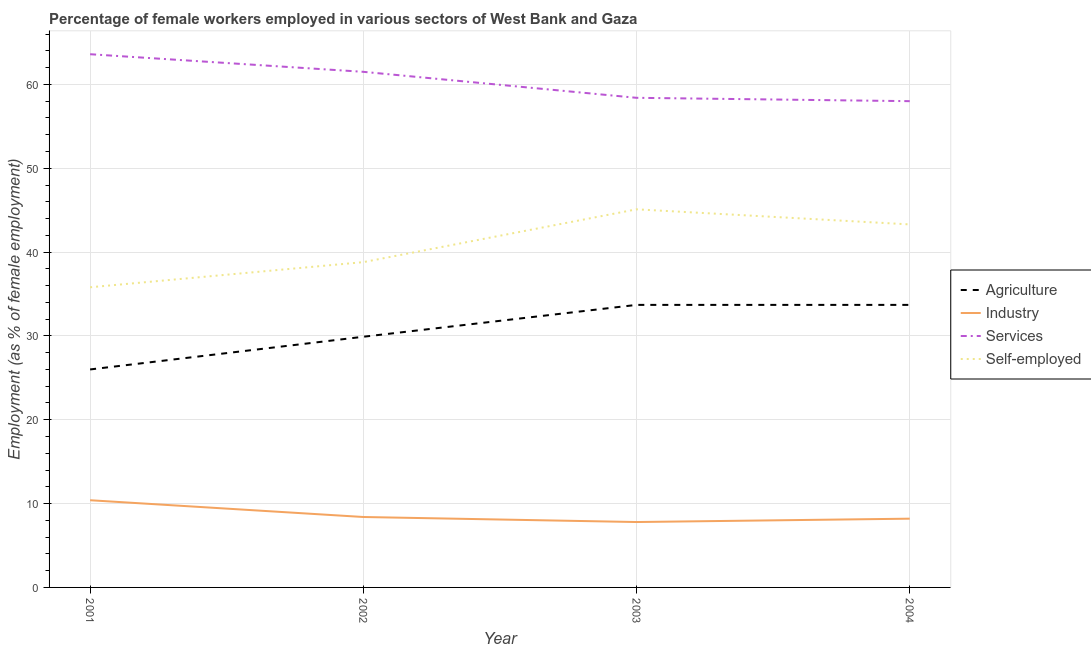How many different coloured lines are there?
Keep it short and to the point. 4. What is the percentage of female workers in industry in 2001?
Your answer should be very brief. 10.4. Across all years, what is the maximum percentage of female workers in services?
Make the answer very short. 63.6. Across all years, what is the minimum percentage of female workers in services?
Keep it short and to the point. 58. In which year was the percentage of female workers in agriculture minimum?
Your answer should be compact. 2001. What is the total percentage of female workers in agriculture in the graph?
Provide a succinct answer. 123.3. What is the difference between the percentage of female workers in industry in 2002 and that in 2004?
Give a very brief answer. 0.2. What is the average percentage of female workers in agriculture per year?
Offer a very short reply. 30.83. In the year 2002, what is the difference between the percentage of self employed female workers and percentage of female workers in services?
Provide a succinct answer. -22.7. In how many years, is the percentage of female workers in industry greater than 18 %?
Provide a succinct answer. 0. What is the ratio of the percentage of female workers in services in 2003 to that in 2004?
Keep it short and to the point. 1.01. Is the percentage of female workers in industry in 2003 less than that in 2004?
Provide a succinct answer. Yes. Is the difference between the percentage of female workers in agriculture in 2001 and 2004 greater than the difference between the percentage of self employed female workers in 2001 and 2004?
Your answer should be very brief. No. What is the difference between the highest and the lowest percentage of female workers in services?
Your answer should be very brief. 5.6. Is the sum of the percentage of self employed female workers in 2003 and 2004 greater than the maximum percentage of female workers in industry across all years?
Give a very brief answer. Yes. Is the percentage of female workers in industry strictly greater than the percentage of self employed female workers over the years?
Give a very brief answer. No. How many lines are there?
Keep it short and to the point. 4. How many years are there in the graph?
Ensure brevity in your answer.  4. What is the difference between two consecutive major ticks on the Y-axis?
Give a very brief answer. 10. Are the values on the major ticks of Y-axis written in scientific E-notation?
Provide a succinct answer. No. Does the graph contain any zero values?
Offer a terse response. No. How many legend labels are there?
Make the answer very short. 4. How are the legend labels stacked?
Ensure brevity in your answer.  Vertical. What is the title of the graph?
Offer a very short reply. Percentage of female workers employed in various sectors of West Bank and Gaza. Does "Agricultural land" appear as one of the legend labels in the graph?
Offer a terse response. No. What is the label or title of the X-axis?
Your answer should be compact. Year. What is the label or title of the Y-axis?
Ensure brevity in your answer.  Employment (as % of female employment). What is the Employment (as % of female employment) of Industry in 2001?
Offer a very short reply. 10.4. What is the Employment (as % of female employment) in Services in 2001?
Provide a succinct answer. 63.6. What is the Employment (as % of female employment) in Self-employed in 2001?
Provide a short and direct response. 35.8. What is the Employment (as % of female employment) in Agriculture in 2002?
Your answer should be very brief. 29.9. What is the Employment (as % of female employment) in Industry in 2002?
Make the answer very short. 8.4. What is the Employment (as % of female employment) in Services in 2002?
Provide a short and direct response. 61.5. What is the Employment (as % of female employment) in Self-employed in 2002?
Your answer should be very brief. 38.8. What is the Employment (as % of female employment) of Agriculture in 2003?
Your answer should be very brief. 33.7. What is the Employment (as % of female employment) in Industry in 2003?
Offer a terse response. 7.8. What is the Employment (as % of female employment) in Services in 2003?
Offer a very short reply. 58.4. What is the Employment (as % of female employment) of Self-employed in 2003?
Your answer should be very brief. 45.1. What is the Employment (as % of female employment) of Agriculture in 2004?
Offer a very short reply. 33.7. What is the Employment (as % of female employment) of Industry in 2004?
Give a very brief answer. 8.2. What is the Employment (as % of female employment) in Services in 2004?
Offer a terse response. 58. What is the Employment (as % of female employment) of Self-employed in 2004?
Offer a terse response. 43.3. Across all years, what is the maximum Employment (as % of female employment) in Agriculture?
Keep it short and to the point. 33.7. Across all years, what is the maximum Employment (as % of female employment) in Industry?
Make the answer very short. 10.4. Across all years, what is the maximum Employment (as % of female employment) of Services?
Provide a short and direct response. 63.6. Across all years, what is the maximum Employment (as % of female employment) of Self-employed?
Ensure brevity in your answer.  45.1. Across all years, what is the minimum Employment (as % of female employment) of Industry?
Give a very brief answer. 7.8. Across all years, what is the minimum Employment (as % of female employment) of Self-employed?
Give a very brief answer. 35.8. What is the total Employment (as % of female employment) in Agriculture in the graph?
Offer a very short reply. 123.3. What is the total Employment (as % of female employment) in Industry in the graph?
Make the answer very short. 34.8. What is the total Employment (as % of female employment) of Services in the graph?
Your response must be concise. 241.5. What is the total Employment (as % of female employment) of Self-employed in the graph?
Offer a very short reply. 163. What is the difference between the Employment (as % of female employment) of Industry in 2001 and that in 2002?
Provide a succinct answer. 2. What is the difference between the Employment (as % of female employment) of Services in 2001 and that in 2002?
Your answer should be very brief. 2.1. What is the difference between the Employment (as % of female employment) in Agriculture in 2001 and that in 2003?
Give a very brief answer. -7.7. What is the difference between the Employment (as % of female employment) of Services in 2001 and that in 2003?
Keep it short and to the point. 5.2. What is the difference between the Employment (as % of female employment) of Self-employed in 2001 and that in 2003?
Make the answer very short. -9.3. What is the difference between the Employment (as % of female employment) of Industry in 2001 and that in 2004?
Your answer should be compact. 2.2. What is the difference between the Employment (as % of female employment) in Services in 2001 and that in 2004?
Offer a very short reply. 5.6. What is the difference between the Employment (as % of female employment) in Self-employed in 2001 and that in 2004?
Provide a short and direct response. -7.5. What is the difference between the Employment (as % of female employment) of Services in 2002 and that in 2003?
Keep it short and to the point. 3.1. What is the difference between the Employment (as % of female employment) in Agriculture in 2002 and that in 2004?
Ensure brevity in your answer.  -3.8. What is the difference between the Employment (as % of female employment) of Services in 2002 and that in 2004?
Your answer should be very brief. 3.5. What is the difference between the Employment (as % of female employment) in Agriculture in 2003 and that in 2004?
Provide a succinct answer. 0. What is the difference between the Employment (as % of female employment) in Industry in 2003 and that in 2004?
Make the answer very short. -0.4. What is the difference between the Employment (as % of female employment) in Services in 2003 and that in 2004?
Give a very brief answer. 0.4. What is the difference between the Employment (as % of female employment) of Self-employed in 2003 and that in 2004?
Give a very brief answer. 1.8. What is the difference between the Employment (as % of female employment) in Agriculture in 2001 and the Employment (as % of female employment) in Industry in 2002?
Ensure brevity in your answer.  17.6. What is the difference between the Employment (as % of female employment) in Agriculture in 2001 and the Employment (as % of female employment) in Services in 2002?
Your response must be concise. -35.5. What is the difference between the Employment (as % of female employment) of Agriculture in 2001 and the Employment (as % of female employment) of Self-employed in 2002?
Offer a terse response. -12.8. What is the difference between the Employment (as % of female employment) of Industry in 2001 and the Employment (as % of female employment) of Services in 2002?
Your answer should be very brief. -51.1. What is the difference between the Employment (as % of female employment) in Industry in 2001 and the Employment (as % of female employment) in Self-employed in 2002?
Offer a terse response. -28.4. What is the difference between the Employment (as % of female employment) of Services in 2001 and the Employment (as % of female employment) of Self-employed in 2002?
Give a very brief answer. 24.8. What is the difference between the Employment (as % of female employment) in Agriculture in 2001 and the Employment (as % of female employment) in Industry in 2003?
Your answer should be compact. 18.2. What is the difference between the Employment (as % of female employment) of Agriculture in 2001 and the Employment (as % of female employment) of Services in 2003?
Your response must be concise. -32.4. What is the difference between the Employment (as % of female employment) of Agriculture in 2001 and the Employment (as % of female employment) of Self-employed in 2003?
Make the answer very short. -19.1. What is the difference between the Employment (as % of female employment) of Industry in 2001 and the Employment (as % of female employment) of Services in 2003?
Offer a terse response. -48. What is the difference between the Employment (as % of female employment) of Industry in 2001 and the Employment (as % of female employment) of Self-employed in 2003?
Keep it short and to the point. -34.7. What is the difference between the Employment (as % of female employment) of Agriculture in 2001 and the Employment (as % of female employment) of Industry in 2004?
Make the answer very short. 17.8. What is the difference between the Employment (as % of female employment) of Agriculture in 2001 and the Employment (as % of female employment) of Services in 2004?
Offer a very short reply. -32. What is the difference between the Employment (as % of female employment) of Agriculture in 2001 and the Employment (as % of female employment) of Self-employed in 2004?
Your response must be concise. -17.3. What is the difference between the Employment (as % of female employment) of Industry in 2001 and the Employment (as % of female employment) of Services in 2004?
Keep it short and to the point. -47.6. What is the difference between the Employment (as % of female employment) in Industry in 2001 and the Employment (as % of female employment) in Self-employed in 2004?
Offer a terse response. -32.9. What is the difference between the Employment (as % of female employment) of Services in 2001 and the Employment (as % of female employment) of Self-employed in 2004?
Provide a succinct answer. 20.3. What is the difference between the Employment (as % of female employment) in Agriculture in 2002 and the Employment (as % of female employment) in Industry in 2003?
Give a very brief answer. 22.1. What is the difference between the Employment (as % of female employment) of Agriculture in 2002 and the Employment (as % of female employment) of Services in 2003?
Give a very brief answer. -28.5. What is the difference between the Employment (as % of female employment) of Agriculture in 2002 and the Employment (as % of female employment) of Self-employed in 2003?
Provide a short and direct response. -15.2. What is the difference between the Employment (as % of female employment) of Industry in 2002 and the Employment (as % of female employment) of Services in 2003?
Provide a short and direct response. -50. What is the difference between the Employment (as % of female employment) of Industry in 2002 and the Employment (as % of female employment) of Self-employed in 2003?
Keep it short and to the point. -36.7. What is the difference between the Employment (as % of female employment) of Services in 2002 and the Employment (as % of female employment) of Self-employed in 2003?
Offer a very short reply. 16.4. What is the difference between the Employment (as % of female employment) of Agriculture in 2002 and the Employment (as % of female employment) of Industry in 2004?
Provide a succinct answer. 21.7. What is the difference between the Employment (as % of female employment) in Agriculture in 2002 and the Employment (as % of female employment) in Services in 2004?
Offer a very short reply. -28.1. What is the difference between the Employment (as % of female employment) of Industry in 2002 and the Employment (as % of female employment) of Services in 2004?
Your answer should be very brief. -49.6. What is the difference between the Employment (as % of female employment) in Industry in 2002 and the Employment (as % of female employment) in Self-employed in 2004?
Make the answer very short. -34.9. What is the difference between the Employment (as % of female employment) of Services in 2002 and the Employment (as % of female employment) of Self-employed in 2004?
Provide a succinct answer. 18.2. What is the difference between the Employment (as % of female employment) of Agriculture in 2003 and the Employment (as % of female employment) of Services in 2004?
Your answer should be compact. -24.3. What is the difference between the Employment (as % of female employment) in Agriculture in 2003 and the Employment (as % of female employment) in Self-employed in 2004?
Offer a very short reply. -9.6. What is the difference between the Employment (as % of female employment) in Industry in 2003 and the Employment (as % of female employment) in Services in 2004?
Offer a very short reply. -50.2. What is the difference between the Employment (as % of female employment) of Industry in 2003 and the Employment (as % of female employment) of Self-employed in 2004?
Make the answer very short. -35.5. What is the difference between the Employment (as % of female employment) in Services in 2003 and the Employment (as % of female employment) in Self-employed in 2004?
Keep it short and to the point. 15.1. What is the average Employment (as % of female employment) in Agriculture per year?
Your response must be concise. 30.82. What is the average Employment (as % of female employment) in Industry per year?
Your response must be concise. 8.7. What is the average Employment (as % of female employment) of Services per year?
Your answer should be compact. 60.38. What is the average Employment (as % of female employment) of Self-employed per year?
Provide a succinct answer. 40.75. In the year 2001, what is the difference between the Employment (as % of female employment) of Agriculture and Employment (as % of female employment) of Industry?
Offer a terse response. 15.6. In the year 2001, what is the difference between the Employment (as % of female employment) of Agriculture and Employment (as % of female employment) of Services?
Offer a very short reply. -37.6. In the year 2001, what is the difference between the Employment (as % of female employment) in Industry and Employment (as % of female employment) in Services?
Give a very brief answer. -53.2. In the year 2001, what is the difference between the Employment (as % of female employment) of Industry and Employment (as % of female employment) of Self-employed?
Give a very brief answer. -25.4. In the year 2001, what is the difference between the Employment (as % of female employment) of Services and Employment (as % of female employment) of Self-employed?
Make the answer very short. 27.8. In the year 2002, what is the difference between the Employment (as % of female employment) of Agriculture and Employment (as % of female employment) of Industry?
Offer a very short reply. 21.5. In the year 2002, what is the difference between the Employment (as % of female employment) in Agriculture and Employment (as % of female employment) in Services?
Give a very brief answer. -31.6. In the year 2002, what is the difference between the Employment (as % of female employment) in Agriculture and Employment (as % of female employment) in Self-employed?
Keep it short and to the point. -8.9. In the year 2002, what is the difference between the Employment (as % of female employment) in Industry and Employment (as % of female employment) in Services?
Ensure brevity in your answer.  -53.1. In the year 2002, what is the difference between the Employment (as % of female employment) of Industry and Employment (as % of female employment) of Self-employed?
Your answer should be very brief. -30.4. In the year 2002, what is the difference between the Employment (as % of female employment) in Services and Employment (as % of female employment) in Self-employed?
Provide a succinct answer. 22.7. In the year 2003, what is the difference between the Employment (as % of female employment) of Agriculture and Employment (as % of female employment) of Industry?
Make the answer very short. 25.9. In the year 2003, what is the difference between the Employment (as % of female employment) of Agriculture and Employment (as % of female employment) of Services?
Make the answer very short. -24.7. In the year 2003, what is the difference between the Employment (as % of female employment) in Agriculture and Employment (as % of female employment) in Self-employed?
Your response must be concise. -11.4. In the year 2003, what is the difference between the Employment (as % of female employment) in Industry and Employment (as % of female employment) in Services?
Make the answer very short. -50.6. In the year 2003, what is the difference between the Employment (as % of female employment) of Industry and Employment (as % of female employment) of Self-employed?
Provide a short and direct response. -37.3. In the year 2003, what is the difference between the Employment (as % of female employment) in Services and Employment (as % of female employment) in Self-employed?
Provide a succinct answer. 13.3. In the year 2004, what is the difference between the Employment (as % of female employment) in Agriculture and Employment (as % of female employment) in Services?
Give a very brief answer. -24.3. In the year 2004, what is the difference between the Employment (as % of female employment) in Industry and Employment (as % of female employment) in Services?
Give a very brief answer. -49.8. In the year 2004, what is the difference between the Employment (as % of female employment) in Industry and Employment (as % of female employment) in Self-employed?
Provide a succinct answer. -35.1. What is the ratio of the Employment (as % of female employment) in Agriculture in 2001 to that in 2002?
Your answer should be compact. 0.87. What is the ratio of the Employment (as % of female employment) of Industry in 2001 to that in 2002?
Offer a very short reply. 1.24. What is the ratio of the Employment (as % of female employment) in Services in 2001 to that in 2002?
Make the answer very short. 1.03. What is the ratio of the Employment (as % of female employment) in Self-employed in 2001 to that in 2002?
Offer a terse response. 0.92. What is the ratio of the Employment (as % of female employment) in Agriculture in 2001 to that in 2003?
Your response must be concise. 0.77. What is the ratio of the Employment (as % of female employment) of Services in 2001 to that in 2003?
Your response must be concise. 1.09. What is the ratio of the Employment (as % of female employment) in Self-employed in 2001 to that in 2003?
Provide a short and direct response. 0.79. What is the ratio of the Employment (as % of female employment) in Agriculture in 2001 to that in 2004?
Keep it short and to the point. 0.77. What is the ratio of the Employment (as % of female employment) in Industry in 2001 to that in 2004?
Keep it short and to the point. 1.27. What is the ratio of the Employment (as % of female employment) of Services in 2001 to that in 2004?
Offer a very short reply. 1.1. What is the ratio of the Employment (as % of female employment) in Self-employed in 2001 to that in 2004?
Keep it short and to the point. 0.83. What is the ratio of the Employment (as % of female employment) of Agriculture in 2002 to that in 2003?
Your answer should be very brief. 0.89. What is the ratio of the Employment (as % of female employment) in Industry in 2002 to that in 2003?
Make the answer very short. 1.08. What is the ratio of the Employment (as % of female employment) of Services in 2002 to that in 2003?
Your answer should be very brief. 1.05. What is the ratio of the Employment (as % of female employment) of Self-employed in 2002 to that in 2003?
Give a very brief answer. 0.86. What is the ratio of the Employment (as % of female employment) in Agriculture in 2002 to that in 2004?
Provide a short and direct response. 0.89. What is the ratio of the Employment (as % of female employment) in Industry in 2002 to that in 2004?
Give a very brief answer. 1.02. What is the ratio of the Employment (as % of female employment) in Services in 2002 to that in 2004?
Ensure brevity in your answer.  1.06. What is the ratio of the Employment (as % of female employment) of Self-employed in 2002 to that in 2004?
Give a very brief answer. 0.9. What is the ratio of the Employment (as % of female employment) in Agriculture in 2003 to that in 2004?
Give a very brief answer. 1. What is the ratio of the Employment (as % of female employment) in Industry in 2003 to that in 2004?
Make the answer very short. 0.95. What is the ratio of the Employment (as % of female employment) in Services in 2003 to that in 2004?
Offer a terse response. 1.01. What is the ratio of the Employment (as % of female employment) of Self-employed in 2003 to that in 2004?
Keep it short and to the point. 1.04. What is the difference between the highest and the second highest Employment (as % of female employment) of Industry?
Give a very brief answer. 2. What is the difference between the highest and the lowest Employment (as % of female employment) of Agriculture?
Ensure brevity in your answer.  7.7. What is the difference between the highest and the lowest Employment (as % of female employment) in Services?
Give a very brief answer. 5.6. 